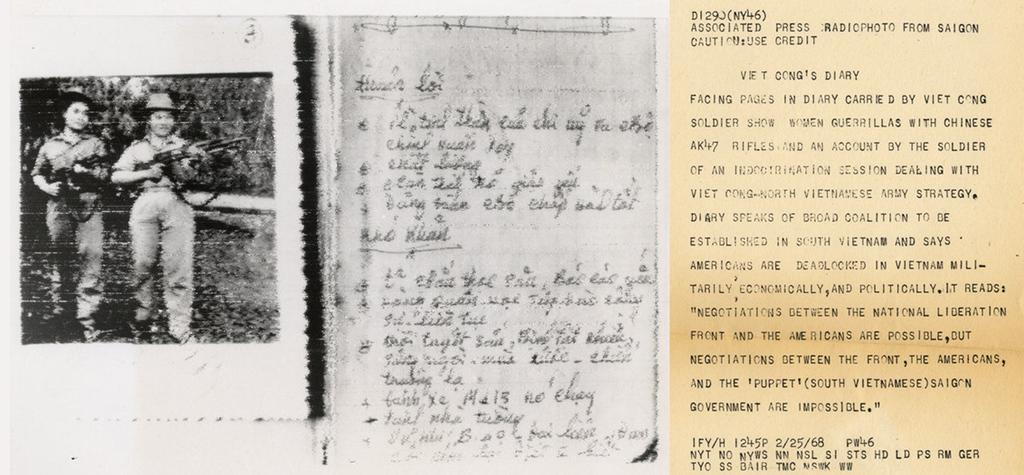How would you summarize this image in a sentence or two? In this image I can see collage photos where on the left side I can see two persons are standing and holding guns. I can also see something is written on the right side. 